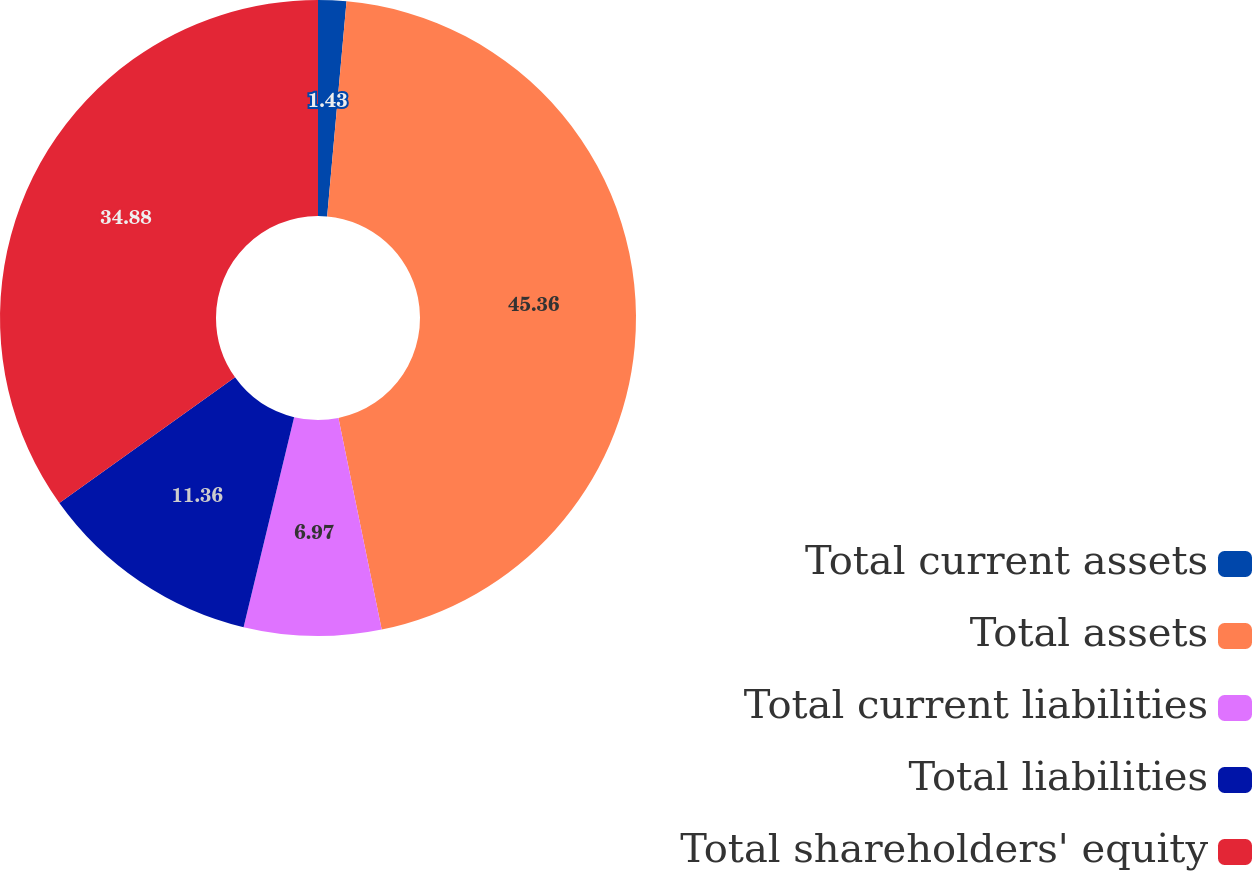<chart> <loc_0><loc_0><loc_500><loc_500><pie_chart><fcel>Total current assets<fcel>Total assets<fcel>Total current liabilities<fcel>Total liabilities<fcel>Total shareholders' equity<nl><fcel>1.43%<fcel>45.36%<fcel>6.97%<fcel>11.36%<fcel>34.88%<nl></chart> 